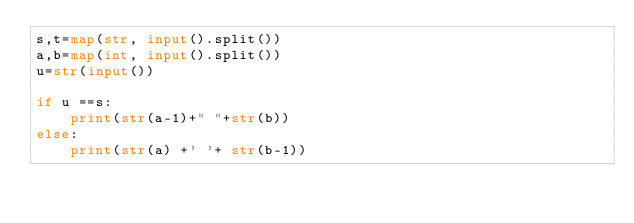<code> <loc_0><loc_0><loc_500><loc_500><_Python_>s,t=map(str, input().split()) 
a,b=map(int, input().split()) 
u=str(input()) 

if u ==s:
    print(str(a-1)+" "+str(b))
else:
    print(str(a) +' '+ str(b-1))</code> 